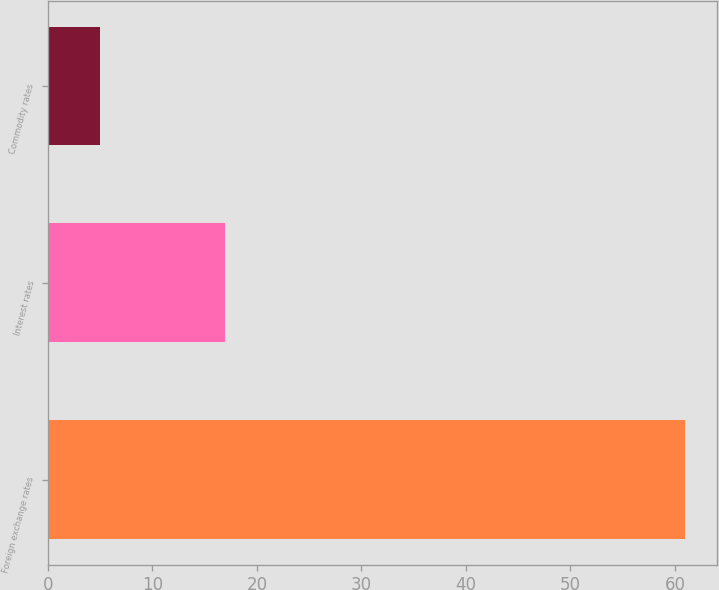Convert chart. <chart><loc_0><loc_0><loc_500><loc_500><bar_chart><fcel>Foreign exchange rates<fcel>Interest rates<fcel>Commodity rates<nl><fcel>61<fcel>17<fcel>5<nl></chart> 